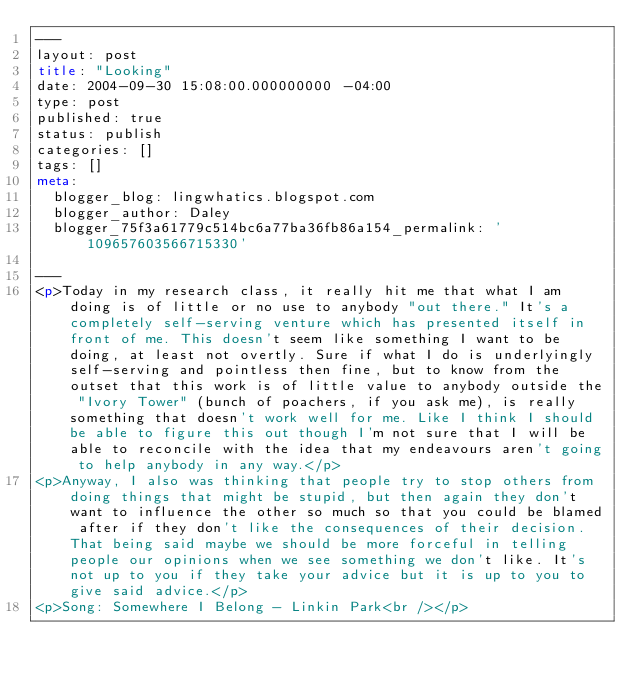<code> <loc_0><loc_0><loc_500><loc_500><_HTML_>---
layout: post
title: "Looking"
date: 2004-09-30 15:08:00.000000000 -04:00
type: post
published: true
status: publish
categories: []
tags: []
meta:
  blogger_blog: lingwhatics.blogspot.com
  blogger_author: Daley
  blogger_75f3a61779c514bc6a77ba36fb86a154_permalink: '109657603566715330'

---
<p>Today in my research class, it really hit me that what I am doing is of little or no use to anybody "out there." It's a completely self-serving venture which has presented itself in front of me. This doesn't seem like something I want to be doing, at least not overtly. Sure if what I do is underlyingly self-serving and pointless then fine, but to know from the outset that this work is of little value to anybody outside the "Ivory Tower" (bunch of poachers, if you ask me), is really something that doesn't work well for me. Like I think I should be able to figure this out though I'm not sure that I will be able to reconcile with the idea that my endeavours aren't going to help anybody in any way.</p>
<p>Anyway, I also was thinking that people try to stop others from doing things that might be stupid, but then again they don't want to influence the other so much so that you could be blamed after if they don't like the consequences of their decision. That being said maybe we should be more forceful in telling people our opinions when we see something we don't like. It's not up to you if they take your advice but it is up to you to give said advice.</p>
<p>Song: Somewhere I Belong - Linkin Park<br /></p>
</code> 